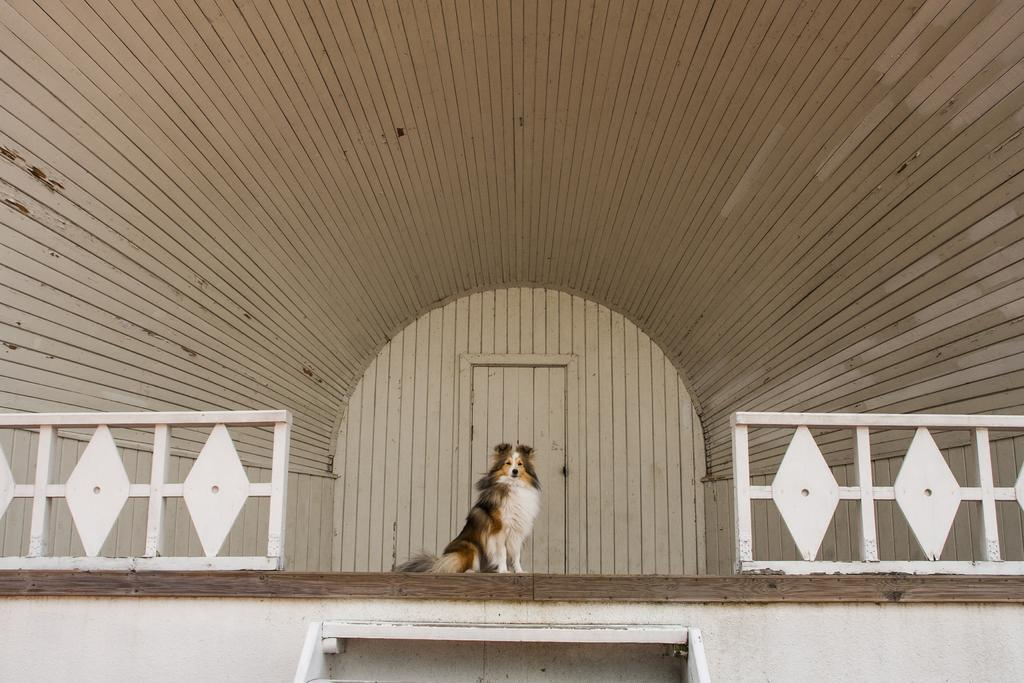What animal is present in the image? There is a dog in the image. Where is the dog located? The dog is sitting on a stage. What architectural feature can be seen in the image? There is a door visible in the image. Are there any steps in the image? Yes, there are stairs in the image. What type of prose is being recited by the dog on the stage? There is no indication in the image that the dog is reciting any prose, as dogs do not have the ability to speak or recite literature. 